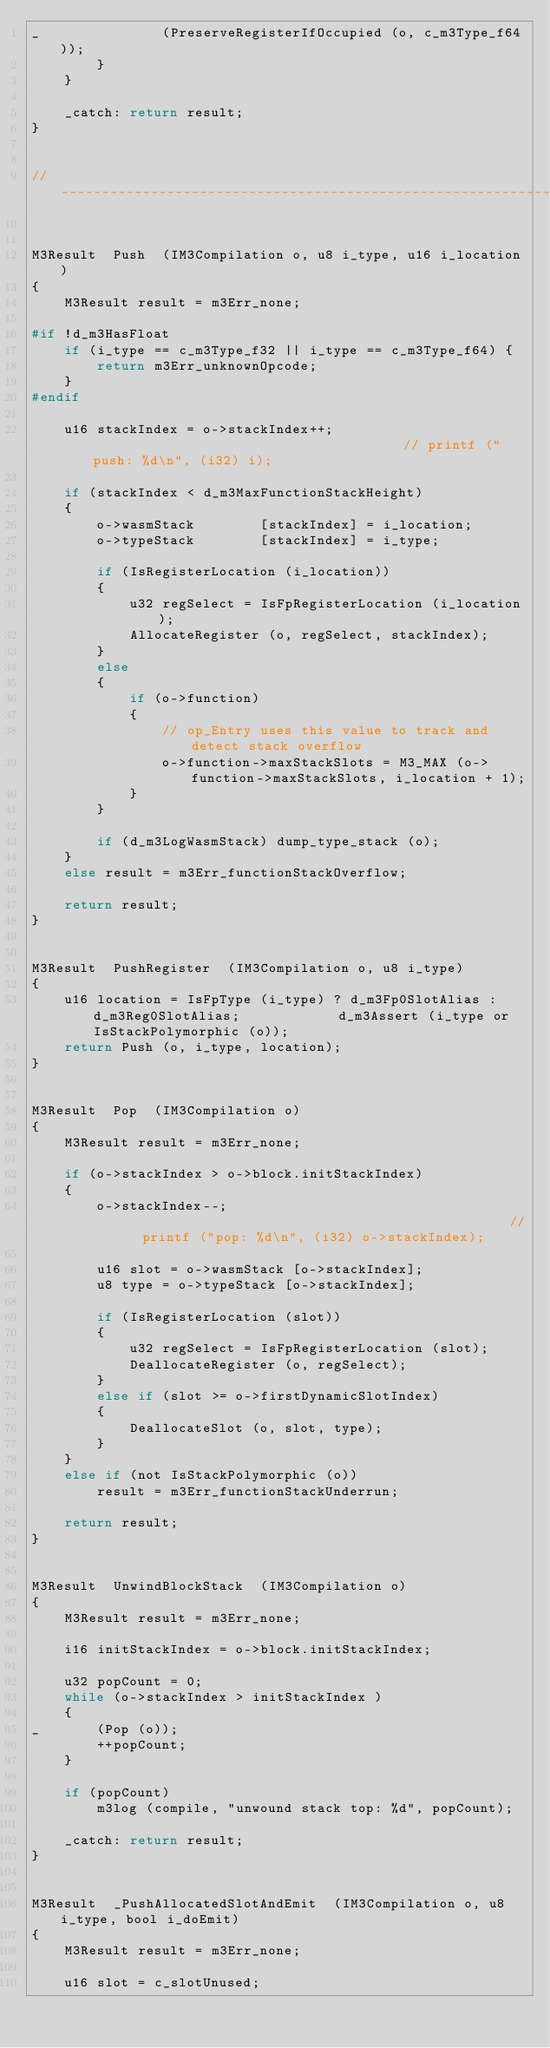<code> <loc_0><loc_0><loc_500><loc_500><_C_>_               (PreserveRegisterIfOccupied (o, c_m3Type_f64));
        }
    }

    _catch: return result;
}


//----------------------------------------------------------------------------------------------------------------------


M3Result  Push  (IM3Compilation o, u8 i_type, u16 i_location)
{
    M3Result result = m3Err_none;

#if !d_m3HasFloat
    if (i_type == c_m3Type_f32 || i_type == c_m3Type_f64) {
        return m3Err_unknownOpcode;
    }
#endif

    u16 stackIndex = o->stackIndex++;                                       // printf ("push: %d\n", (i32) i);

    if (stackIndex < d_m3MaxFunctionStackHeight)
    {
        o->wasmStack        [stackIndex] = i_location;
        o->typeStack        [stackIndex] = i_type;

        if (IsRegisterLocation (i_location))
        {
            u32 regSelect = IsFpRegisterLocation (i_location);
            AllocateRegister (o, regSelect, stackIndex);
        }
        else
        {
            if (o->function)
            {
                // op_Entry uses this value to track and detect stack overflow
                o->function->maxStackSlots = M3_MAX (o->function->maxStackSlots, i_location + 1);
            }
        }

        if (d_m3LogWasmStack) dump_type_stack (o);
    }
    else result = m3Err_functionStackOverflow;

    return result;
}


M3Result  PushRegister  (IM3Compilation o, u8 i_type)
{
    u16 location = IsFpType (i_type) ? d_m3Fp0SlotAlias : d_m3Reg0SlotAlias;            d_m3Assert (i_type or IsStackPolymorphic (o));
    return Push (o, i_type, location);
}


M3Result  Pop  (IM3Compilation o)
{
    M3Result result = m3Err_none;

    if (o->stackIndex > o->block.initStackIndex)
    {
        o->stackIndex--;                                                //  printf ("pop: %d\n", (i32) o->stackIndex);

        u16 slot = o->wasmStack [o->stackIndex];
        u8 type = o->typeStack [o->stackIndex];

        if (IsRegisterLocation (slot))
        {
            u32 regSelect = IsFpRegisterLocation (slot);
            DeallocateRegister (o, regSelect);
        }
        else if (slot >= o->firstDynamicSlotIndex)
        {
            DeallocateSlot (o, slot, type);
        }
    }
    else if (not IsStackPolymorphic (o))
        result = m3Err_functionStackUnderrun;

    return result;
}


M3Result  UnwindBlockStack  (IM3Compilation o)
{
    M3Result result = m3Err_none;

    i16 initStackIndex = o->block.initStackIndex;

    u32 popCount = 0;
    while (o->stackIndex > initStackIndex )
    {
_       (Pop (o));
        ++popCount;
    }

    if (popCount)
        m3log (compile, "unwound stack top: %d", popCount);

    _catch: return result;
}


M3Result  _PushAllocatedSlotAndEmit  (IM3Compilation o, u8 i_type, bool i_doEmit)
{
    M3Result result = m3Err_none;

    u16 slot = c_slotUnused;
</code> 